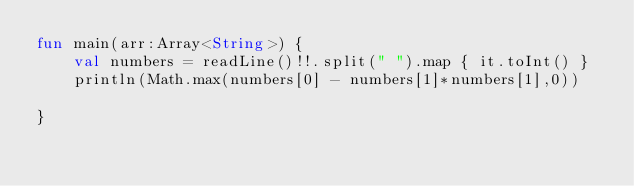<code> <loc_0><loc_0><loc_500><loc_500><_Kotlin_>fun main(arr:Array<String>) {
    val numbers = readLine()!!.split(" ").map { it.toInt() }
    println(Math.max(numbers[0] - numbers[1]*numbers[1],0))

}</code> 